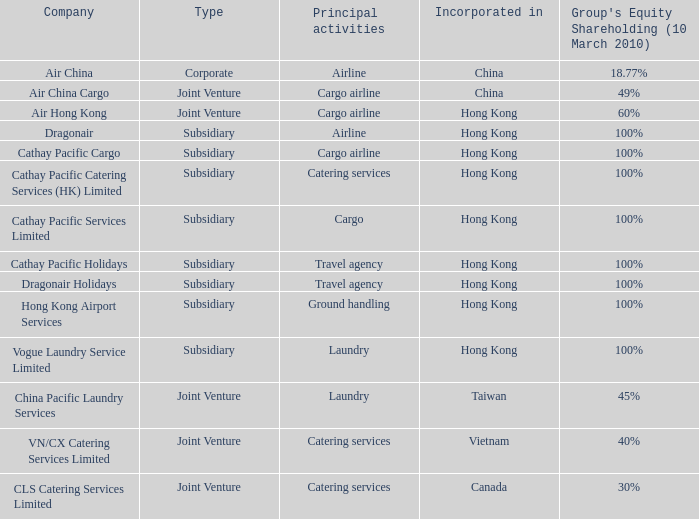What is the type for the Cathay Pacific Holidays company, an incorporation of Hong Kong and listed activities as Travel Agency? Subsidiary. 